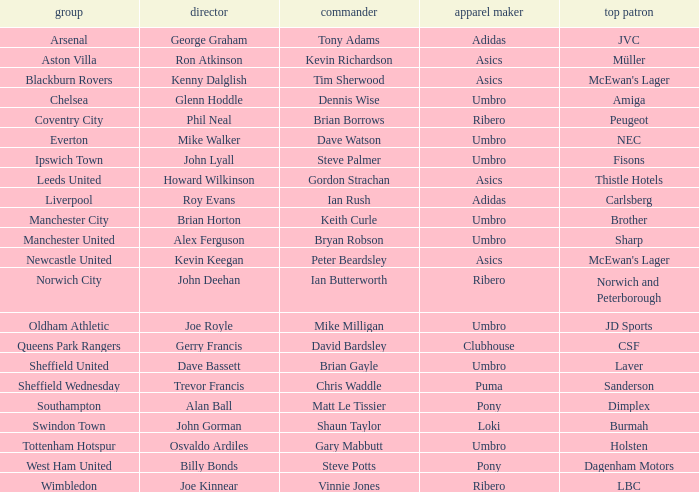Can you parse all the data within this table? {'header': ['group', 'director', 'commander', 'apparel maker', 'top patron'], 'rows': [['Arsenal', 'George Graham', 'Tony Adams', 'Adidas', 'JVC'], ['Aston Villa', 'Ron Atkinson', 'Kevin Richardson', 'Asics', 'Müller'], ['Blackburn Rovers', 'Kenny Dalglish', 'Tim Sherwood', 'Asics', "McEwan's Lager"], ['Chelsea', 'Glenn Hoddle', 'Dennis Wise', 'Umbro', 'Amiga'], ['Coventry City', 'Phil Neal', 'Brian Borrows', 'Ribero', 'Peugeot'], ['Everton', 'Mike Walker', 'Dave Watson', 'Umbro', 'NEC'], ['Ipswich Town', 'John Lyall', 'Steve Palmer', 'Umbro', 'Fisons'], ['Leeds United', 'Howard Wilkinson', 'Gordon Strachan', 'Asics', 'Thistle Hotels'], ['Liverpool', 'Roy Evans', 'Ian Rush', 'Adidas', 'Carlsberg'], ['Manchester City', 'Brian Horton', 'Keith Curle', 'Umbro', 'Brother'], ['Manchester United', 'Alex Ferguson', 'Bryan Robson', 'Umbro', 'Sharp'], ['Newcastle United', 'Kevin Keegan', 'Peter Beardsley', 'Asics', "McEwan's Lager"], ['Norwich City', 'John Deehan', 'Ian Butterworth', 'Ribero', 'Norwich and Peterborough'], ['Oldham Athletic', 'Joe Royle', 'Mike Milligan', 'Umbro', 'JD Sports'], ['Queens Park Rangers', 'Gerry Francis', 'David Bardsley', 'Clubhouse', 'CSF'], ['Sheffield United', 'Dave Bassett', 'Brian Gayle', 'Umbro', 'Laver'], ['Sheffield Wednesday', 'Trevor Francis', 'Chris Waddle', 'Puma', 'Sanderson'], ['Southampton', 'Alan Ball', 'Matt Le Tissier', 'Pony', 'Dimplex'], ['Swindon Town', 'John Gorman', 'Shaun Taylor', 'Loki', 'Burmah'], ['Tottenham Hotspur', 'Osvaldo Ardiles', 'Gary Mabbutt', 'Umbro', 'Holsten'], ['West Ham United', 'Billy Bonds', 'Steve Potts', 'Pony', 'Dagenham Motors'], ['Wimbledon', 'Joe Kinnear', 'Vinnie Jones', 'Ribero', 'LBC']]} Which manager has sheffield wednesday as the team? Trevor Francis. 